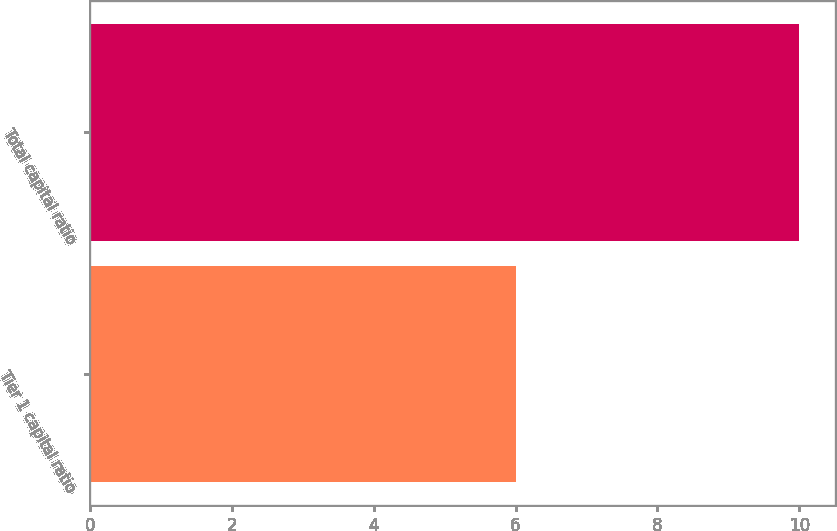<chart> <loc_0><loc_0><loc_500><loc_500><bar_chart><fcel>Tier 1 capital ratio<fcel>Total capital ratio<nl><fcel>6<fcel>10<nl></chart> 